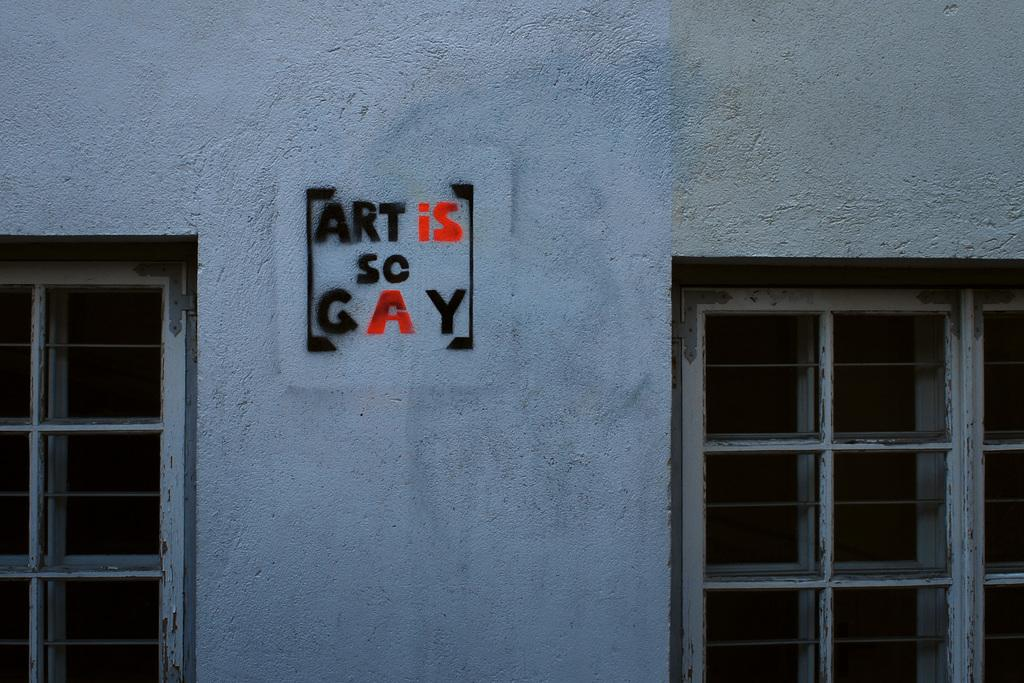What can be seen on the wall in the image? There is text on a wall in the image. What feature is common in buildings and is visible in the image? There are windows in the image. What type of pipe is visible in the image? There is no pipe present in the image. How does the fog affect the visibility of the text on the wall in the image? There is no fog present in the image, so it does not affect the visibility of the text on the wall. 